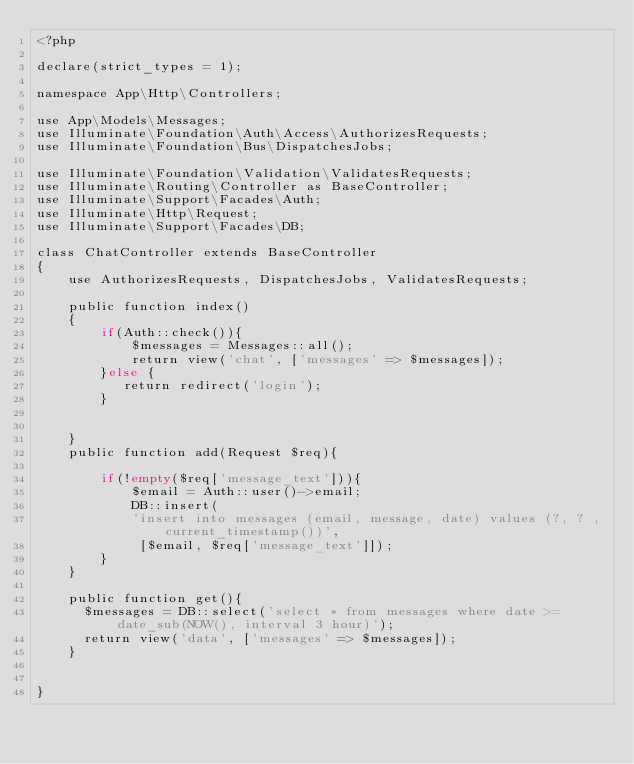Convert code to text. <code><loc_0><loc_0><loc_500><loc_500><_PHP_><?php

declare(strict_types = 1);

namespace App\Http\Controllers;

use App\Models\Messages;
use Illuminate\Foundation\Auth\Access\AuthorizesRequests;
use Illuminate\Foundation\Bus\DispatchesJobs;

use Illuminate\Foundation\Validation\ValidatesRequests;
use Illuminate\Routing\Controller as BaseController;
use Illuminate\Support\Facades\Auth;
use Illuminate\Http\Request;
use Illuminate\Support\Facades\DB;

class ChatController extends BaseController
{
    use AuthorizesRequests, DispatchesJobs, ValidatesRequests;

    public function index()
    {
        if(Auth::check()){
            $messages = Messages::all();
            return view('chat', ['messages' => $messages]);
        }else {
           return redirect('login');
        }
        

    }
    public function add(Request $req){
        
        if(!empty($req['message_text'])){
            $email = Auth::user()->email;
            DB::insert(
            'insert into messages (email, message, date) values (?, ? , current_timestamp())',
             [$email, $req['message_text']]); 
        }
    }

    public function get(){
      $messages = DB::select('select * from messages where date >= date_sub(NOW(), interval 3 hour)');
      return view('data', ['messages' => $messages]);
    }


}
</code> 